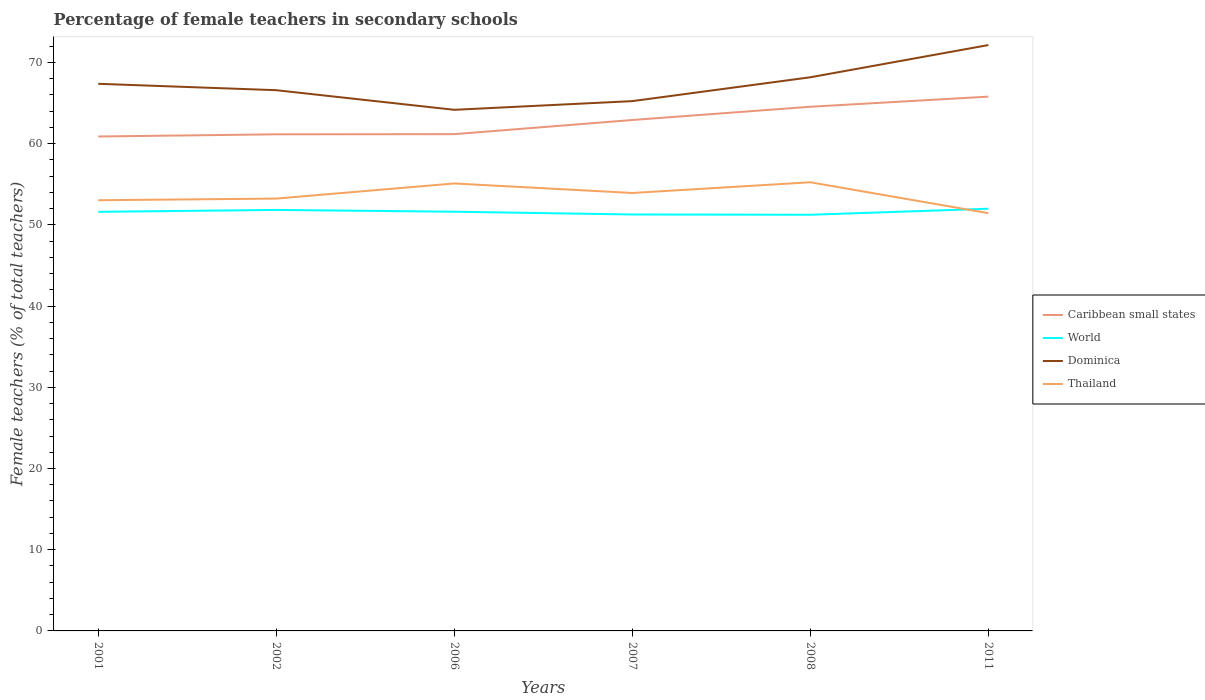How many different coloured lines are there?
Offer a very short reply. 4. Across all years, what is the maximum percentage of female teachers in Dominica?
Your answer should be very brief. 64.18. In which year was the percentage of female teachers in Thailand maximum?
Your response must be concise. 2011. What is the total percentage of female teachers in Caribbean small states in the graph?
Offer a very short reply. -1.76. What is the difference between the highest and the second highest percentage of female teachers in World?
Give a very brief answer. 0.74. What is the difference between the highest and the lowest percentage of female teachers in World?
Provide a short and direct response. 4. Is the percentage of female teachers in Caribbean small states strictly greater than the percentage of female teachers in Thailand over the years?
Your answer should be compact. No. What is the difference between two consecutive major ticks on the Y-axis?
Your answer should be very brief. 10. Does the graph contain any zero values?
Your answer should be very brief. No. Where does the legend appear in the graph?
Keep it short and to the point. Center right. How are the legend labels stacked?
Ensure brevity in your answer.  Vertical. What is the title of the graph?
Provide a short and direct response. Percentage of female teachers in secondary schools. What is the label or title of the X-axis?
Your response must be concise. Years. What is the label or title of the Y-axis?
Give a very brief answer. Female teachers (% of total teachers). What is the Female teachers (% of total teachers) in Caribbean small states in 2001?
Offer a very short reply. 60.89. What is the Female teachers (% of total teachers) in World in 2001?
Make the answer very short. 51.61. What is the Female teachers (% of total teachers) of Dominica in 2001?
Keep it short and to the point. 67.38. What is the Female teachers (% of total teachers) in Thailand in 2001?
Your answer should be compact. 53.04. What is the Female teachers (% of total teachers) of Caribbean small states in 2002?
Ensure brevity in your answer.  61.16. What is the Female teachers (% of total teachers) in World in 2002?
Your response must be concise. 51.85. What is the Female teachers (% of total teachers) of Dominica in 2002?
Your answer should be very brief. 66.59. What is the Female teachers (% of total teachers) of Thailand in 2002?
Offer a very short reply. 53.24. What is the Female teachers (% of total teachers) of Caribbean small states in 2006?
Keep it short and to the point. 61.18. What is the Female teachers (% of total teachers) of World in 2006?
Your response must be concise. 51.62. What is the Female teachers (% of total teachers) in Dominica in 2006?
Provide a short and direct response. 64.18. What is the Female teachers (% of total teachers) of Thailand in 2006?
Your answer should be compact. 55.11. What is the Female teachers (% of total teachers) in Caribbean small states in 2007?
Offer a very short reply. 62.92. What is the Female teachers (% of total teachers) in World in 2007?
Provide a short and direct response. 51.28. What is the Female teachers (% of total teachers) of Dominica in 2007?
Your answer should be compact. 65.25. What is the Female teachers (% of total teachers) of Thailand in 2007?
Your answer should be compact. 53.93. What is the Female teachers (% of total teachers) in Caribbean small states in 2008?
Give a very brief answer. 64.55. What is the Female teachers (% of total teachers) of World in 2008?
Your response must be concise. 51.25. What is the Female teachers (% of total teachers) of Dominica in 2008?
Keep it short and to the point. 68.18. What is the Female teachers (% of total teachers) in Thailand in 2008?
Give a very brief answer. 55.25. What is the Female teachers (% of total teachers) of Caribbean small states in 2011?
Give a very brief answer. 65.8. What is the Female teachers (% of total teachers) in World in 2011?
Give a very brief answer. 51.99. What is the Female teachers (% of total teachers) in Dominica in 2011?
Keep it short and to the point. 72.15. What is the Female teachers (% of total teachers) in Thailand in 2011?
Provide a short and direct response. 51.45. Across all years, what is the maximum Female teachers (% of total teachers) in Caribbean small states?
Offer a very short reply. 65.8. Across all years, what is the maximum Female teachers (% of total teachers) in World?
Offer a very short reply. 51.99. Across all years, what is the maximum Female teachers (% of total teachers) of Dominica?
Keep it short and to the point. 72.15. Across all years, what is the maximum Female teachers (% of total teachers) of Thailand?
Your response must be concise. 55.25. Across all years, what is the minimum Female teachers (% of total teachers) of Caribbean small states?
Your answer should be very brief. 60.89. Across all years, what is the minimum Female teachers (% of total teachers) in World?
Offer a very short reply. 51.25. Across all years, what is the minimum Female teachers (% of total teachers) in Dominica?
Your answer should be compact. 64.18. Across all years, what is the minimum Female teachers (% of total teachers) in Thailand?
Your answer should be compact. 51.45. What is the total Female teachers (% of total teachers) in Caribbean small states in the graph?
Offer a terse response. 376.49. What is the total Female teachers (% of total teachers) of World in the graph?
Your answer should be compact. 309.61. What is the total Female teachers (% of total teachers) in Dominica in the graph?
Ensure brevity in your answer.  403.72. What is the total Female teachers (% of total teachers) of Thailand in the graph?
Keep it short and to the point. 322.02. What is the difference between the Female teachers (% of total teachers) in Caribbean small states in 2001 and that in 2002?
Keep it short and to the point. -0.27. What is the difference between the Female teachers (% of total teachers) in World in 2001 and that in 2002?
Your response must be concise. -0.24. What is the difference between the Female teachers (% of total teachers) of Dominica in 2001 and that in 2002?
Your answer should be very brief. 0.79. What is the difference between the Female teachers (% of total teachers) of Thailand in 2001 and that in 2002?
Your answer should be very brief. -0.2. What is the difference between the Female teachers (% of total teachers) of Caribbean small states in 2001 and that in 2006?
Your answer should be compact. -0.29. What is the difference between the Female teachers (% of total teachers) of World in 2001 and that in 2006?
Provide a short and direct response. -0.01. What is the difference between the Female teachers (% of total teachers) in Dominica in 2001 and that in 2006?
Your answer should be compact. 3.2. What is the difference between the Female teachers (% of total teachers) in Thailand in 2001 and that in 2006?
Keep it short and to the point. -2.06. What is the difference between the Female teachers (% of total teachers) in Caribbean small states in 2001 and that in 2007?
Make the answer very short. -2.03. What is the difference between the Female teachers (% of total teachers) of World in 2001 and that in 2007?
Your answer should be very brief. 0.33. What is the difference between the Female teachers (% of total teachers) in Dominica in 2001 and that in 2007?
Ensure brevity in your answer.  2.13. What is the difference between the Female teachers (% of total teachers) of Thailand in 2001 and that in 2007?
Keep it short and to the point. -0.89. What is the difference between the Female teachers (% of total teachers) of Caribbean small states in 2001 and that in 2008?
Provide a short and direct response. -3.66. What is the difference between the Female teachers (% of total teachers) of World in 2001 and that in 2008?
Keep it short and to the point. 0.36. What is the difference between the Female teachers (% of total teachers) in Dominica in 2001 and that in 2008?
Offer a very short reply. -0.8. What is the difference between the Female teachers (% of total teachers) in Thailand in 2001 and that in 2008?
Provide a short and direct response. -2.21. What is the difference between the Female teachers (% of total teachers) in Caribbean small states in 2001 and that in 2011?
Ensure brevity in your answer.  -4.91. What is the difference between the Female teachers (% of total teachers) of World in 2001 and that in 2011?
Your answer should be compact. -0.38. What is the difference between the Female teachers (% of total teachers) in Dominica in 2001 and that in 2011?
Make the answer very short. -4.77. What is the difference between the Female teachers (% of total teachers) of Thailand in 2001 and that in 2011?
Keep it short and to the point. 1.59. What is the difference between the Female teachers (% of total teachers) of Caribbean small states in 2002 and that in 2006?
Offer a very short reply. -0.02. What is the difference between the Female teachers (% of total teachers) in World in 2002 and that in 2006?
Provide a short and direct response. 0.22. What is the difference between the Female teachers (% of total teachers) in Dominica in 2002 and that in 2006?
Provide a short and direct response. 2.42. What is the difference between the Female teachers (% of total teachers) in Thailand in 2002 and that in 2006?
Give a very brief answer. -1.86. What is the difference between the Female teachers (% of total teachers) of Caribbean small states in 2002 and that in 2007?
Your response must be concise. -1.76. What is the difference between the Female teachers (% of total teachers) in World in 2002 and that in 2007?
Your answer should be compact. 0.56. What is the difference between the Female teachers (% of total teachers) of Dominica in 2002 and that in 2007?
Make the answer very short. 1.35. What is the difference between the Female teachers (% of total teachers) in Thailand in 2002 and that in 2007?
Keep it short and to the point. -0.69. What is the difference between the Female teachers (% of total teachers) of Caribbean small states in 2002 and that in 2008?
Your answer should be very brief. -3.39. What is the difference between the Female teachers (% of total teachers) of World in 2002 and that in 2008?
Ensure brevity in your answer.  0.6. What is the difference between the Female teachers (% of total teachers) of Dominica in 2002 and that in 2008?
Offer a terse response. -1.59. What is the difference between the Female teachers (% of total teachers) in Thailand in 2002 and that in 2008?
Make the answer very short. -2.01. What is the difference between the Female teachers (% of total teachers) in Caribbean small states in 2002 and that in 2011?
Provide a succinct answer. -4.64. What is the difference between the Female teachers (% of total teachers) in World in 2002 and that in 2011?
Keep it short and to the point. -0.15. What is the difference between the Female teachers (% of total teachers) in Dominica in 2002 and that in 2011?
Ensure brevity in your answer.  -5.56. What is the difference between the Female teachers (% of total teachers) of Thailand in 2002 and that in 2011?
Offer a very short reply. 1.79. What is the difference between the Female teachers (% of total teachers) of Caribbean small states in 2006 and that in 2007?
Your answer should be compact. -1.74. What is the difference between the Female teachers (% of total teachers) of World in 2006 and that in 2007?
Give a very brief answer. 0.34. What is the difference between the Female teachers (% of total teachers) of Dominica in 2006 and that in 2007?
Your response must be concise. -1.07. What is the difference between the Female teachers (% of total teachers) in Thailand in 2006 and that in 2007?
Provide a succinct answer. 1.17. What is the difference between the Female teachers (% of total teachers) in Caribbean small states in 2006 and that in 2008?
Give a very brief answer. -3.37. What is the difference between the Female teachers (% of total teachers) in World in 2006 and that in 2008?
Ensure brevity in your answer.  0.37. What is the difference between the Female teachers (% of total teachers) in Dominica in 2006 and that in 2008?
Your answer should be very brief. -4.01. What is the difference between the Female teachers (% of total teachers) of Thailand in 2006 and that in 2008?
Keep it short and to the point. -0.15. What is the difference between the Female teachers (% of total teachers) in Caribbean small states in 2006 and that in 2011?
Ensure brevity in your answer.  -4.62. What is the difference between the Female teachers (% of total teachers) of World in 2006 and that in 2011?
Provide a short and direct response. -0.37. What is the difference between the Female teachers (% of total teachers) in Dominica in 2006 and that in 2011?
Keep it short and to the point. -7.97. What is the difference between the Female teachers (% of total teachers) of Thailand in 2006 and that in 2011?
Give a very brief answer. 3.66. What is the difference between the Female teachers (% of total teachers) of Caribbean small states in 2007 and that in 2008?
Ensure brevity in your answer.  -1.63. What is the difference between the Female teachers (% of total teachers) of World in 2007 and that in 2008?
Offer a terse response. 0.03. What is the difference between the Female teachers (% of total teachers) in Dominica in 2007 and that in 2008?
Keep it short and to the point. -2.94. What is the difference between the Female teachers (% of total teachers) of Thailand in 2007 and that in 2008?
Offer a very short reply. -1.32. What is the difference between the Female teachers (% of total teachers) in Caribbean small states in 2007 and that in 2011?
Keep it short and to the point. -2.88. What is the difference between the Female teachers (% of total teachers) of World in 2007 and that in 2011?
Your response must be concise. -0.71. What is the difference between the Female teachers (% of total teachers) in Dominica in 2007 and that in 2011?
Offer a terse response. -6.9. What is the difference between the Female teachers (% of total teachers) of Thailand in 2007 and that in 2011?
Keep it short and to the point. 2.48. What is the difference between the Female teachers (% of total teachers) of Caribbean small states in 2008 and that in 2011?
Your response must be concise. -1.25. What is the difference between the Female teachers (% of total teachers) of World in 2008 and that in 2011?
Ensure brevity in your answer.  -0.74. What is the difference between the Female teachers (% of total teachers) of Dominica in 2008 and that in 2011?
Your answer should be compact. -3.97. What is the difference between the Female teachers (% of total teachers) of Thailand in 2008 and that in 2011?
Your answer should be very brief. 3.8. What is the difference between the Female teachers (% of total teachers) of Caribbean small states in 2001 and the Female teachers (% of total teachers) of World in 2002?
Your answer should be very brief. 9.04. What is the difference between the Female teachers (% of total teachers) in Caribbean small states in 2001 and the Female teachers (% of total teachers) in Dominica in 2002?
Provide a short and direct response. -5.7. What is the difference between the Female teachers (% of total teachers) of Caribbean small states in 2001 and the Female teachers (% of total teachers) of Thailand in 2002?
Ensure brevity in your answer.  7.65. What is the difference between the Female teachers (% of total teachers) in World in 2001 and the Female teachers (% of total teachers) in Dominica in 2002?
Provide a short and direct response. -14.98. What is the difference between the Female teachers (% of total teachers) in World in 2001 and the Female teachers (% of total teachers) in Thailand in 2002?
Provide a short and direct response. -1.63. What is the difference between the Female teachers (% of total teachers) in Dominica in 2001 and the Female teachers (% of total teachers) in Thailand in 2002?
Offer a terse response. 14.14. What is the difference between the Female teachers (% of total teachers) of Caribbean small states in 2001 and the Female teachers (% of total teachers) of World in 2006?
Provide a succinct answer. 9.26. What is the difference between the Female teachers (% of total teachers) of Caribbean small states in 2001 and the Female teachers (% of total teachers) of Dominica in 2006?
Ensure brevity in your answer.  -3.29. What is the difference between the Female teachers (% of total teachers) in Caribbean small states in 2001 and the Female teachers (% of total teachers) in Thailand in 2006?
Provide a succinct answer. 5.78. What is the difference between the Female teachers (% of total teachers) in World in 2001 and the Female teachers (% of total teachers) in Dominica in 2006?
Keep it short and to the point. -12.56. What is the difference between the Female teachers (% of total teachers) of World in 2001 and the Female teachers (% of total teachers) of Thailand in 2006?
Provide a succinct answer. -3.49. What is the difference between the Female teachers (% of total teachers) of Dominica in 2001 and the Female teachers (% of total teachers) of Thailand in 2006?
Provide a short and direct response. 12.27. What is the difference between the Female teachers (% of total teachers) of Caribbean small states in 2001 and the Female teachers (% of total teachers) of World in 2007?
Keep it short and to the point. 9.6. What is the difference between the Female teachers (% of total teachers) in Caribbean small states in 2001 and the Female teachers (% of total teachers) in Dominica in 2007?
Keep it short and to the point. -4.36. What is the difference between the Female teachers (% of total teachers) in Caribbean small states in 2001 and the Female teachers (% of total teachers) in Thailand in 2007?
Your answer should be compact. 6.95. What is the difference between the Female teachers (% of total teachers) of World in 2001 and the Female teachers (% of total teachers) of Dominica in 2007?
Give a very brief answer. -13.63. What is the difference between the Female teachers (% of total teachers) in World in 2001 and the Female teachers (% of total teachers) in Thailand in 2007?
Make the answer very short. -2.32. What is the difference between the Female teachers (% of total teachers) of Dominica in 2001 and the Female teachers (% of total teachers) of Thailand in 2007?
Make the answer very short. 13.45. What is the difference between the Female teachers (% of total teachers) of Caribbean small states in 2001 and the Female teachers (% of total teachers) of World in 2008?
Make the answer very short. 9.64. What is the difference between the Female teachers (% of total teachers) in Caribbean small states in 2001 and the Female teachers (% of total teachers) in Dominica in 2008?
Provide a short and direct response. -7.29. What is the difference between the Female teachers (% of total teachers) in Caribbean small states in 2001 and the Female teachers (% of total teachers) in Thailand in 2008?
Keep it short and to the point. 5.64. What is the difference between the Female teachers (% of total teachers) of World in 2001 and the Female teachers (% of total teachers) of Dominica in 2008?
Offer a very short reply. -16.57. What is the difference between the Female teachers (% of total teachers) in World in 2001 and the Female teachers (% of total teachers) in Thailand in 2008?
Ensure brevity in your answer.  -3.64. What is the difference between the Female teachers (% of total teachers) in Dominica in 2001 and the Female teachers (% of total teachers) in Thailand in 2008?
Provide a succinct answer. 12.13. What is the difference between the Female teachers (% of total teachers) of Caribbean small states in 2001 and the Female teachers (% of total teachers) of World in 2011?
Ensure brevity in your answer.  8.9. What is the difference between the Female teachers (% of total teachers) of Caribbean small states in 2001 and the Female teachers (% of total teachers) of Dominica in 2011?
Make the answer very short. -11.26. What is the difference between the Female teachers (% of total teachers) in Caribbean small states in 2001 and the Female teachers (% of total teachers) in Thailand in 2011?
Give a very brief answer. 9.44. What is the difference between the Female teachers (% of total teachers) in World in 2001 and the Female teachers (% of total teachers) in Dominica in 2011?
Make the answer very short. -20.54. What is the difference between the Female teachers (% of total teachers) in World in 2001 and the Female teachers (% of total teachers) in Thailand in 2011?
Offer a terse response. 0.16. What is the difference between the Female teachers (% of total teachers) in Dominica in 2001 and the Female teachers (% of total teachers) in Thailand in 2011?
Give a very brief answer. 15.93. What is the difference between the Female teachers (% of total teachers) of Caribbean small states in 2002 and the Female teachers (% of total teachers) of World in 2006?
Make the answer very short. 9.53. What is the difference between the Female teachers (% of total teachers) of Caribbean small states in 2002 and the Female teachers (% of total teachers) of Dominica in 2006?
Your answer should be very brief. -3.02. What is the difference between the Female teachers (% of total teachers) of Caribbean small states in 2002 and the Female teachers (% of total teachers) of Thailand in 2006?
Provide a succinct answer. 6.05. What is the difference between the Female teachers (% of total teachers) of World in 2002 and the Female teachers (% of total teachers) of Dominica in 2006?
Offer a terse response. -12.33. What is the difference between the Female teachers (% of total teachers) in World in 2002 and the Female teachers (% of total teachers) in Thailand in 2006?
Provide a short and direct response. -3.26. What is the difference between the Female teachers (% of total teachers) in Dominica in 2002 and the Female teachers (% of total teachers) in Thailand in 2006?
Give a very brief answer. 11.49. What is the difference between the Female teachers (% of total teachers) in Caribbean small states in 2002 and the Female teachers (% of total teachers) in World in 2007?
Ensure brevity in your answer.  9.87. What is the difference between the Female teachers (% of total teachers) in Caribbean small states in 2002 and the Female teachers (% of total teachers) in Dominica in 2007?
Offer a very short reply. -4.09. What is the difference between the Female teachers (% of total teachers) in Caribbean small states in 2002 and the Female teachers (% of total teachers) in Thailand in 2007?
Your answer should be very brief. 7.22. What is the difference between the Female teachers (% of total teachers) of World in 2002 and the Female teachers (% of total teachers) of Dominica in 2007?
Give a very brief answer. -13.4. What is the difference between the Female teachers (% of total teachers) of World in 2002 and the Female teachers (% of total teachers) of Thailand in 2007?
Provide a short and direct response. -2.09. What is the difference between the Female teachers (% of total teachers) of Dominica in 2002 and the Female teachers (% of total teachers) of Thailand in 2007?
Keep it short and to the point. 12.66. What is the difference between the Female teachers (% of total teachers) of Caribbean small states in 2002 and the Female teachers (% of total teachers) of World in 2008?
Ensure brevity in your answer.  9.91. What is the difference between the Female teachers (% of total teachers) of Caribbean small states in 2002 and the Female teachers (% of total teachers) of Dominica in 2008?
Make the answer very short. -7.02. What is the difference between the Female teachers (% of total teachers) in Caribbean small states in 2002 and the Female teachers (% of total teachers) in Thailand in 2008?
Make the answer very short. 5.91. What is the difference between the Female teachers (% of total teachers) of World in 2002 and the Female teachers (% of total teachers) of Dominica in 2008?
Ensure brevity in your answer.  -16.33. What is the difference between the Female teachers (% of total teachers) of World in 2002 and the Female teachers (% of total teachers) of Thailand in 2008?
Provide a short and direct response. -3.4. What is the difference between the Female teachers (% of total teachers) in Dominica in 2002 and the Female teachers (% of total teachers) in Thailand in 2008?
Make the answer very short. 11.34. What is the difference between the Female teachers (% of total teachers) in Caribbean small states in 2002 and the Female teachers (% of total teachers) in World in 2011?
Your response must be concise. 9.16. What is the difference between the Female teachers (% of total teachers) of Caribbean small states in 2002 and the Female teachers (% of total teachers) of Dominica in 2011?
Your answer should be very brief. -10.99. What is the difference between the Female teachers (% of total teachers) of Caribbean small states in 2002 and the Female teachers (% of total teachers) of Thailand in 2011?
Offer a terse response. 9.71. What is the difference between the Female teachers (% of total teachers) in World in 2002 and the Female teachers (% of total teachers) in Dominica in 2011?
Provide a succinct answer. -20.3. What is the difference between the Female teachers (% of total teachers) in World in 2002 and the Female teachers (% of total teachers) in Thailand in 2011?
Give a very brief answer. 0.4. What is the difference between the Female teachers (% of total teachers) of Dominica in 2002 and the Female teachers (% of total teachers) of Thailand in 2011?
Your response must be concise. 15.14. What is the difference between the Female teachers (% of total teachers) of Caribbean small states in 2006 and the Female teachers (% of total teachers) of World in 2007?
Your answer should be compact. 9.89. What is the difference between the Female teachers (% of total teachers) in Caribbean small states in 2006 and the Female teachers (% of total teachers) in Dominica in 2007?
Offer a terse response. -4.07. What is the difference between the Female teachers (% of total teachers) of Caribbean small states in 2006 and the Female teachers (% of total teachers) of Thailand in 2007?
Your answer should be very brief. 7.24. What is the difference between the Female teachers (% of total teachers) of World in 2006 and the Female teachers (% of total teachers) of Dominica in 2007?
Provide a succinct answer. -13.62. What is the difference between the Female teachers (% of total teachers) in World in 2006 and the Female teachers (% of total teachers) in Thailand in 2007?
Your response must be concise. -2.31. What is the difference between the Female teachers (% of total teachers) in Dominica in 2006 and the Female teachers (% of total teachers) in Thailand in 2007?
Offer a very short reply. 10.24. What is the difference between the Female teachers (% of total teachers) in Caribbean small states in 2006 and the Female teachers (% of total teachers) in World in 2008?
Your answer should be compact. 9.93. What is the difference between the Female teachers (% of total teachers) in Caribbean small states in 2006 and the Female teachers (% of total teachers) in Dominica in 2008?
Your answer should be compact. -7. What is the difference between the Female teachers (% of total teachers) in Caribbean small states in 2006 and the Female teachers (% of total teachers) in Thailand in 2008?
Your response must be concise. 5.93. What is the difference between the Female teachers (% of total teachers) in World in 2006 and the Female teachers (% of total teachers) in Dominica in 2008?
Provide a succinct answer. -16.56. What is the difference between the Female teachers (% of total teachers) of World in 2006 and the Female teachers (% of total teachers) of Thailand in 2008?
Keep it short and to the point. -3.63. What is the difference between the Female teachers (% of total teachers) of Dominica in 2006 and the Female teachers (% of total teachers) of Thailand in 2008?
Provide a short and direct response. 8.92. What is the difference between the Female teachers (% of total teachers) in Caribbean small states in 2006 and the Female teachers (% of total teachers) in World in 2011?
Keep it short and to the point. 9.18. What is the difference between the Female teachers (% of total teachers) of Caribbean small states in 2006 and the Female teachers (% of total teachers) of Dominica in 2011?
Provide a succinct answer. -10.97. What is the difference between the Female teachers (% of total teachers) of Caribbean small states in 2006 and the Female teachers (% of total teachers) of Thailand in 2011?
Provide a succinct answer. 9.73. What is the difference between the Female teachers (% of total teachers) of World in 2006 and the Female teachers (% of total teachers) of Dominica in 2011?
Make the answer very short. -20.52. What is the difference between the Female teachers (% of total teachers) in World in 2006 and the Female teachers (% of total teachers) in Thailand in 2011?
Offer a very short reply. 0.17. What is the difference between the Female teachers (% of total teachers) of Dominica in 2006 and the Female teachers (% of total teachers) of Thailand in 2011?
Ensure brevity in your answer.  12.73. What is the difference between the Female teachers (% of total teachers) of Caribbean small states in 2007 and the Female teachers (% of total teachers) of World in 2008?
Provide a succinct answer. 11.67. What is the difference between the Female teachers (% of total teachers) of Caribbean small states in 2007 and the Female teachers (% of total teachers) of Dominica in 2008?
Your answer should be very brief. -5.26. What is the difference between the Female teachers (% of total teachers) in Caribbean small states in 2007 and the Female teachers (% of total teachers) in Thailand in 2008?
Your answer should be very brief. 7.67. What is the difference between the Female teachers (% of total teachers) of World in 2007 and the Female teachers (% of total teachers) of Dominica in 2008?
Give a very brief answer. -16.9. What is the difference between the Female teachers (% of total teachers) of World in 2007 and the Female teachers (% of total teachers) of Thailand in 2008?
Your response must be concise. -3.97. What is the difference between the Female teachers (% of total teachers) in Dominica in 2007 and the Female teachers (% of total teachers) in Thailand in 2008?
Your answer should be compact. 9.99. What is the difference between the Female teachers (% of total teachers) in Caribbean small states in 2007 and the Female teachers (% of total teachers) in World in 2011?
Give a very brief answer. 10.93. What is the difference between the Female teachers (% of total teachers) of Caribbean small states in 2007 and the Female teachers (% of total teachers) of Dominica in 2011?
Offer a very short reply. -9.23. What is the difference between the Female teachers (% of total teachers) of Caribbean small states in 2007 and the Female teachers (% of total teachers) of Thailand in 2011?
Ensure brevity in your answer.  11.47. What is the difference between the Female teachers (% of total teachers) of World in 2007 and the Female teachers (% of total teachers) of Dominica in 2011?
Offer a terse response. -20.87. What is the difference between the Female teachers (% of total teachers) in World in 2007 and the Female teachers (% of total teachers) in Thailand in 2011?
Provide a succinct answer. -0.17. What is the difference between the Female teachers (% of total teachers) of Dominica in 2007 and the Female teachers (% of total teachers) of Thailand in 2011?
Give a very brief answer. 13.8. What is the difference between the Female teachers (% of total teachers) in Caribbean small states in 2008 and the Female teachers (% of total teachers) in World in 2011?
Offer a very short reply. 12.56. What is the difference between the Female teachers (% of total teachers) in Caribbean small states in 2008 and the Female teachers (% of total teachers) in Dominica in 2011?
Offer a very short reply. -7.6. What is the difference between the Female teachers (% of total teachers) of Caribbean small states in 2008 and the Female teachers (% of total teachers) of Thailand in 2011?
Your response must be concise. 13.1. What is the difference between the Female teachers (% of total teachers) in World in 2008 and the Female teachers (% of total teachers) in Dominica in 2011?
Give a very brief answer. -20.9. What is the difference between the Female teachers (% of total teachers) of World in 2008 and the Female teachers (% of total teachers) of Thailand in 2011?
Keep it short and to the point. -0.2. What is the difference between the Female teachers (% of total teachers) in Dominica in 2008 and the Female teachers (% of total teachers) in Thailand in 2011?
Your response must be concise. 16.73. What is the average Female teachers (% of total teachers) in Caribbean small states per year?
Provide a succinct answer. 62.75. What is the average Female teachers (% of total teachers) of World per year?
Provide a short and direct response. 51.6. What is the average Female teachers (% of total teachers) in Dominica per year?
Make the answer very short. 67.29. What is the average Female teachers (% of total teachers) in Thailand per year?
Ensure brevity in your answer.  53.67. In the year 2001, what is the difference between the Female teachers (% of total teachers) in Caribbean small states and Female teachers (% of total teachers) in World?
Ensure brevity in your answer.  9.28. In the year 2001, what is the difference between the Female teachers (% of total teachers) of Caribbean small states and Female teachers (% of total teachers) of Dominica?
Your response must be concise. -6.49. In the year 2001, what is the difference between the Female teachers (% of total teachers) of Caribbean small states and Female teachers (% of total teachers) of Thailand?
Offer a terse response. 7.85. In the year 2001, what is the difference between the Female teachers (% of total teachers) in World and Female teachers (% of total teachers) in Dominica?
Give a very brief answer. -15.77. In the year 2001, what is the difference between the Female teachers (% of total teachers) in World and Female teachers (% of total teachers) in Thailand?
Provide a succinct answer. -1.43. In the year 2001, what is the difference between the Female teachers (% of total teachers) in Dominica and Female teachers (% of total teachers) in Thailand?
Your answer should be compact. 14.34. In the year 2002, what is the difference between the Female teachers (% of total teachers) of Caribbean small states and Female teachers (% of total teachers) of World?
Keep it short and to the point. 9.31. In the year 2002, what is the difference between the Female teachers (% of total teachers) in Caribbean small states and Female teachers (% of total teachers) in Dominica?
Provide a succinct answer. -5.43. In the year 2002, what is the difference between the Female teachers (% of total teachers) of Caribbean small states and Female teachers (% of total teachers) of Thailand?
Provide a succinct answer. 7.92. In the year 2002, what is the difference between the Female teachers (% of total teachers) of World and Female teachers (% of total teachers) of Dominica?
Ensure brevity in your answer.  -14.74. In the year 2002, what is the difference between the Female teachers (% of total teachers) of World and Female teachers (% of total teachers) of Thailand?
Offer a very short reply. -1.4. In the year 2002, what is the difference between the Female teachers (% of total teachers) in Dominica and Female teachers (% of total teachers) in Thailand?
Your answer should be compact. 13.35. In the year 2006, what is the difference between the Female teachers (% of total teachers) of Caribbean small states and Female teachers (% of total teachers) of World?
Your answer should be very brief. 9.55. In the year 2006, what is the difference between the Female teachers (% of total teachers) of Caribbean small states and Female teachers (% of total teachers) of Dominica?
Ensure brevity in your answer.  -3. In the year 2006, what is the difference between the Female teachers (% of total teachers) in Caribbean small states and Female teachers (% of total teachers) in Thailand?
Give a very brief answer. 6.07. In the year 2006, what is the difference between the Female teachers (% of total teachers) in World and Female teachers (% of total teachers) in Dominica?
Your answer should be compact. -12.55. In the year 2006, what is the difference between the Female teachers (% of total teachers) in World and Female teachers (% of total teachers) in Thailand?
Your response must be concise. -3.48. In the year 2006, what is the difference between the Female teachers (% of total teachers) in Dominica and Female teachers (% of total teachers) in Thailand?
Provide a short and direct response. 9.07. In the year 2007, what is the difference between the Female teachers (% of total teachers) in Caribbean small states and Female teachers (% of total teachers) in World?
Make the answer very short. 11.64. In the year 2007, what is the difference between the Female teachers (% of total teachers) in Caribbean small states and Female teachers (% of total teachers) in Dominica?
Keep it short and to the point. -2.32. In the year 2007, what is the difference between the Female teachers (% of total teachers) in Caribbean small states and Female teachers (% of total teachers) in Thailand?
Offer a terse response. 8.99. In the year 2007, what is the difference between the Female teachers (% of total teachers) of World and Female teachers (% of total teachers) of Dominica?
Provide a succinct answer. -13.96. In the year 2007, what is the difference between the Female teachers (% of total teachers) in World and Female teachers (% of total teachers) in Thailand?
Offer a very short reply. -2.65. In the year 2007, what is the difference between the Female teachers (% of total teachers) of Dominica and Female teachers (% of total teachers) of Thailand?
Offer a very short reply. 11.31. In the year 2008, what is the difference between the Female teachers (% of total teachers) in Caribbean small states and Female teachers (% of total teachers) in World?
Make the answer very short. 13.3. In the year 2008, what is the difference between the Female teachers (% of total teachers) in Caribbean small states and Female teachers (% of total teachers) in Dominica?
Provide a succinct answer. -3.63. In the year 2008, what is the difference between the Female teachers (% of total teachers) of Caribbean small states and Female teachers (% of total teachers) of Thailand?
Your response must be concise. 9.3. In the year 2008, what is the difference between the Female teachers (% of total teachers) in World and Female teachers (% of total teachers) in Dominica?
Your answer should be compact. -16.93. In the year 2008, what is the difference between the Female teachers (% of total teachers) in World and Female teachers (% of total teachers) in Thailand?
Your answer should be very brief. -4. In the year 2008, what is the difference between the Female teachers (% of total teachers) of Dominica and Female teachers (% of total teachers) of Thailand?
Keep it short and to the point. 12.93. In the year 2011, what is the difference between the Female teachers (% of total teachers) in Caribbean small states and Female teachers (% of total teachers) in World?
Provide a succinct answer. 13.8. In the year 2011, what is the difference between the Female teachers (% of total teachers) in Caribbean small states and Female teachers (% of total teachers) in Dominica?
Keep it short and to the point. -6.35. In the year 2011, what is the difference between the Female teachers (% of total teachers) of Caribbean small states and Female teachers (% of total teachers) of Thailand?
Make the answer very short. 14.35. In the year 2011, what is the difference between the Female teachers (% of total teachers) in World and Female teachers (% of total teachers) in Dominica?
Your answer should be very brief. -20.16. In the year 2011, what is the difference between the Female teachers (% of total teachers) of World and Female teachers (% of total teachers) of Thailand?
Provide a short and direct response. 0.54. In the year 2011, what is the difference between the Female teachers (% of total teachers) of Dominica and Female teachers (% of total teachers) of Thailand?
Keep it short and to the point. 20.7. What is the ratio of the Female teachers (% of total teachers) of Caribbean small states in 2001 to that in 2002?
Keep it short and to the point. 1. What is the ratio of the Female teachers (% of total teachers) of Dominica in 2001 to that in 2002?
Offer a very short reply. 1.01. What is the ratio of the Female teachers (% of total teachers) in Thailand in 2001 to that in 2002?
Your answer should be compact. 1. What is the ratio of the Female teachers (% of total teachers) in Caribbean small states in 2001 to that in 2006?
Offer a very short reply. 1. What is the ratio of the Female teachers (% of total teachers) in World in 2001 to that in 2006?
Give a very brief answer. 1. What is the ratio of the Female teachers (% of total teachers) in Dominica in 2001 to that in 2006?
Give a very brief answer. 1.05. What is the ratio of the Female teachers (% of total teachers) in Thailand in 2001 to that in 2006?
Your answer should be very brief. 0.96. What is the ratio of the Female teachers (% of total teachers) of World in 2001 to that in 2007?
Ensure brevity in your answer.  1.01. What is the ratio of the Female teachers (% of total teachers) in Dominica in 2001 to that in 2007?
Offer a very short reply. 1.03. What is the ratio of the Female teachers (% of total teachers) in Thailand in 2001 to that in 2007?
Offer a very short reply. 0.98. What is the ratio of the Female teachers (% of total teachers) of Caribbean small states in 2001 to that in 2008?
Offer a very short reply. 0.94. What is the ratio of the Female teachers (% of total teachers) in World in 2001 to that in 2008?
Ensure brevity in your answer.  1.01. What is the ratio of the Female teachers (% of total teachers) of Caribbean small states in 2001 to that in 2011?
Provide a short and direct response. 0.93. What is the ratio of the Female teachers (% of total teachers) in World in 2001 to that in 2011?
Keep it short and to the point. 0.99. What is the ratio of the Female teachers (% of total teachers) of Dominica in 2001 to that in 2011?
Ensure brevity in your answer.  0.93. What is the ratio of the Female teachers (% of total teachers) of Thailand in 2001 to that in 2011?
Keep it short and to the point. 1.03. What is the ratio of the Female teachers (% of total teachers) in Dominica in 2002 to that in 2006?
Offer a terse response. 1.04. What is the ratio of the Female teachers (% of total teachers) in Thailand in 2002 to that in 2006?
Give a very brief answer. 0.97. What is the ratio of the Female teachers (% of total teachers) of Caribbean small states in 2002 to that in 2007?
Offer a very short reply. 0.97. What is the ratio of the Female teachers (% of total teachers) of Dominica in 2002 to that in 2007?
Offer a terse response. 1.02. What is the ratio of the Female teachers (% of total teachers) of Thailand in 2002 to that in 2007?
Keep it short and to the point. 0.99. What is the ratio of the Female teachers (% of total teachers) of World in 2002 to that in 2008?
Give a very brief answer. 1.01. What is the ratio of the Female teachers (% of total teachers) in Dominica in 2002 to that in 2008?
Give a very brief answer. 0.98. What is the ratio of the Female teachers (% of total teachers) in Thailand in 2002 to that in 2008?
Your response must be concise. 0.96. What is the ratio of the Female teachers (% of total teachers) of Caribbean small states in 2002 to that in 2011?
Provide a short and direct response. 0.93. What is the ratio of the Female teachers (% of total teachers) of World in 2002 to that in 2011?
Ensure brevity in your answer.  1. What is the ratio of the Female teachers (% of total teachers) of Dominica in 2002 to that in 2011?
Provide a short and direct response. 0.92. What is the ratio of the Female teachers (% of total teachers) in Thailand in 2002 to that in 2011?
Keep it short and to the point. 1.03. What is the ratio of the Female teachers (% of total teachers) in Caribbean small states in 2006 to that in 2007?
Your response must be concise. 0.97. What is the ratio of the Female teachers (% of total teachers) of World in 2006 to that in 2007?
Keep it short and to the point. 1.01. What is the ratio of the Female teachers (% of total teachers) in Dominica in 2006 to that in 2007?
Your answer should be very brief. 0.98. What is the ratio of the Female teachers (% of total teachers) of Thailand in 2006 to that in 2007?
Your response must be concise. 1.02. What is the ratio of the Female teachers (% of total teachers) of Caribbean small states in 2006 to that in 2008?
Provide a succinct answer. 0.95. What is the ratio of the Female teachers (% of total teachers) of World in 2006 to that in 2008?
Provide a succinct answer. 1.01. What is the ratio of the Female teachers (% of total teachers) of Dominica in 2006 to that in 2008?
Provide a succinct answer. 0.94. What is the ratio of the Female teachers (% of total teachers) in Caribbean small states in 2006 to that in 2011?
Provide a short and direct response. 0.93. What is the ratio of the Female teachers (% of total teachers) in World in 2006 to that in 2011?
Give a very brief answer. 0.99. What is the ratio of the Female teachers (% of total teachers) in Dominica in 2006 to that in 2011?
Offer a very short reply. 0.89. What is the ratio of the Female teachers (% of total teachers) of Thailand in 2006 to that in 2011?
Your answer should be very brief. 1.07. What is the ratio of the Female teachers (% of total teachers) in Caribbean small states in 2007 to that in 2008?
Provide a short and direct response. 0.97. What is the ratio of the Female teachers (% of total teachers) in Dominica in 2007 to that in 2008?
Provide a succinct answer. 0.96. What is the ratio of the Female teachers (% of total teachers) of Thailand in 2007 to that in 2008?
Make the answer very short. 0.98. What is the ratio of the Female teachers (% of total teachers) of Caribbean small states in 2007 to that in 2011?
Ensure brevity in your answer.  0.96. What is the ratio of the Female teachers (% of total teachers) of World in 2007 to that in 2011?
Make the answer very short. 0.99. What is the ratio of the Female teachers (% of total teachers) of Dominica in 2007 to that in 2011?
Keep it short and to the point. 0.9. What is the ratio of the Female teachers (% of total teachers) of Thailand in 2007 to that in 2011?
Offer a very short reply. 1.05. What is the ratio of the Female teachers (% of total teachers) of Caribbean small states in 2008 to that in 2011?
Offer a very short reply. 0.98. What is the ratio of the Female teachers (% of total teachers) in World in 2008 to that in 2011?
Offer a terse response. 0.99. What is the ratio of the Female teachers (% of total teachers) of Dominica in 2008 to that in 2011?
Make the answer very short. 0.94. What is the ratio of the Female teachers (% of total teachers) of Thailand in 2008 to that in 2011?
Your response must be concise. 1.07. What is the difference between the highest and the second highest Female teachers (% of total teachers) of Caribbean small states?
Your answer should be very brief. 1.25. What is the difference between the highest and the second highest Female teachers (% of total teachers) of World?
Give a very brief answer. 0.15. What is the difference between the highest and the second highest Female teachers (% of total teachers) in Dominica?
Your response must be concise. 3.97. What is the difference between the highest and the second highest Female teachers (% of total teachers) in Thailand?
Your answer should be very brief. 0.15. What is the difference between the highest and the lowest Female teachers (% of total teachers) in Caribbean small states?
Offer a terse response. 4.91. What is the difference between the highest and the lowest Female teachers (% of total teachers) in World?
Provide a succinct answer. 0.74. What is the difference between the highest and the lowest Female teachers (% of total teachers) of Dominica?
Offer a terse response. 7.97. What is the difference between the highest and the lowest Female teachers (% of total teachers) in Thailand?
Make the answer very short. 3.8. 